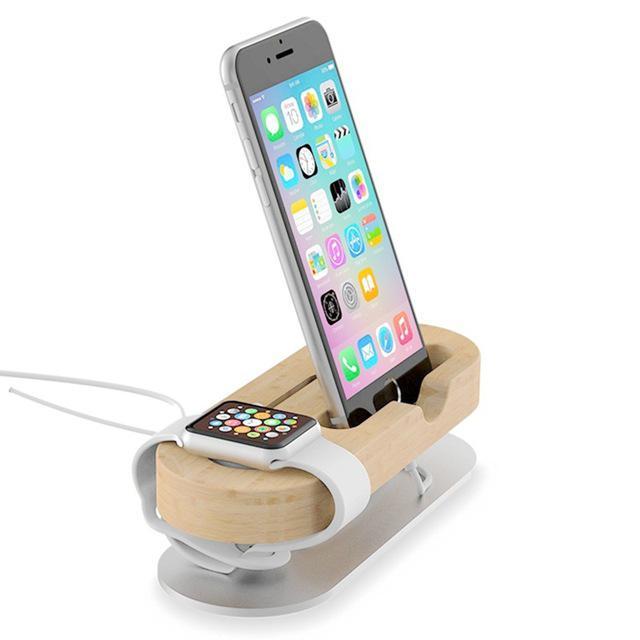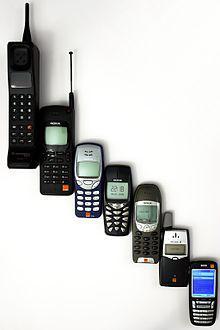The first image is the image on the left, the second image is the image on the right. Assess this claim about the two images: "There are less than 4 phones.". Correct or not? Answer yes or no. No. The first image is the image on the left, the second image is the image on the right. For the images displayed, is the sentence "The combined images include two handsets that rest in silver stands and have a bright blue square screen on black." factually correct? Answer yes or no. No. 